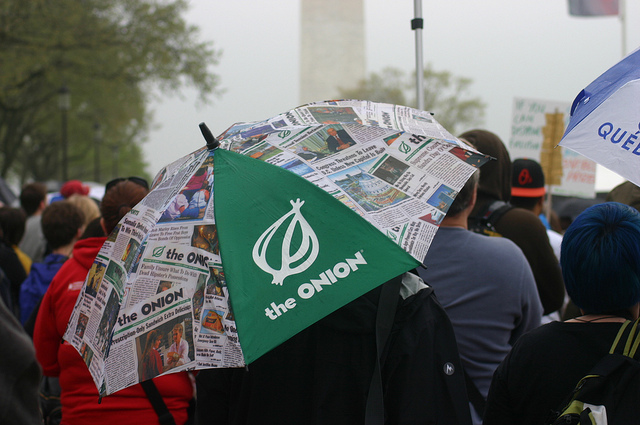Identify and read out the text in this image. the ONION the ONION the 